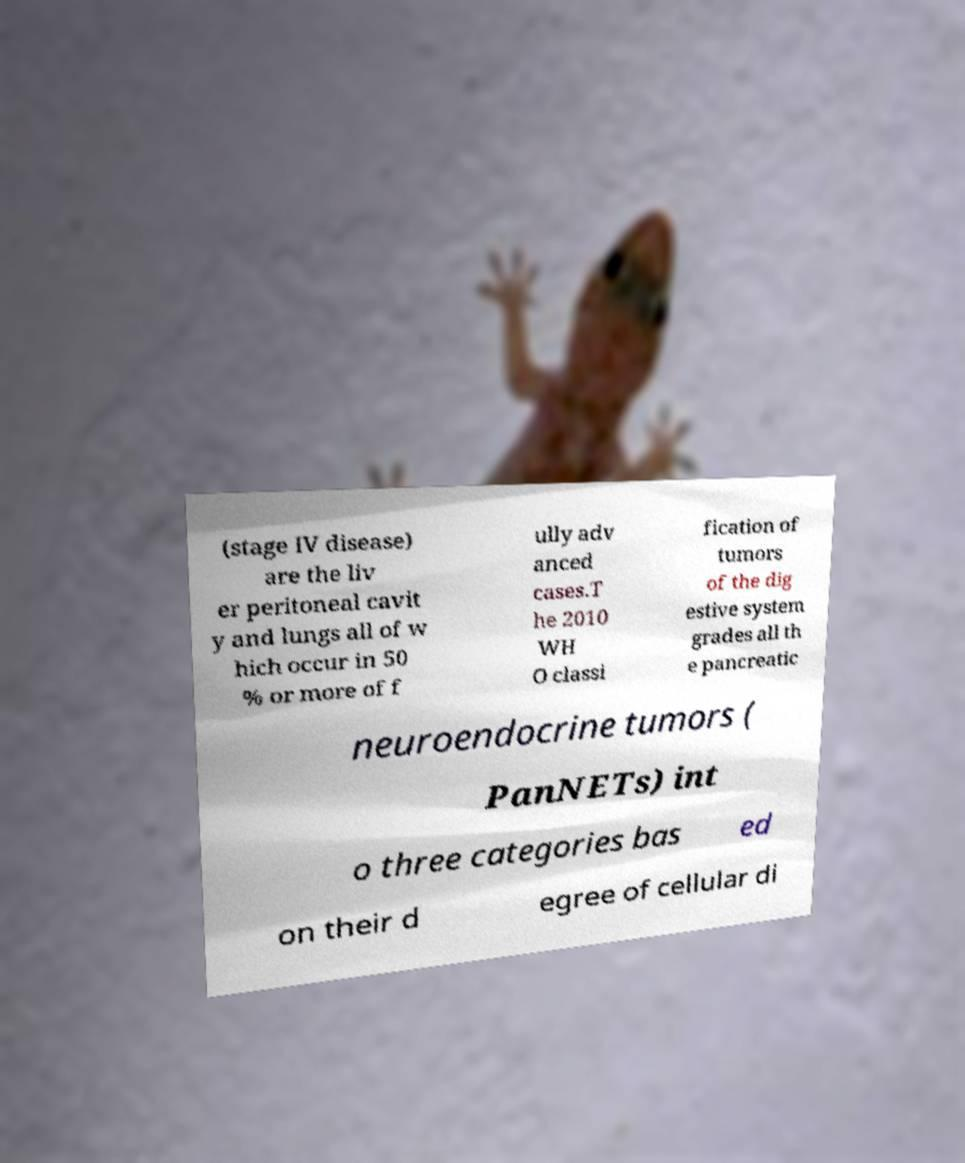Could you assist in decoding the text presented in this image and type it out clearly? (stage IV disease) are the liv er peritoneal cavit y and lungs all of w hich occur in 50 % or more of f ully adv anced cases.T he 2010 WH O classi fication of tumors of the dig estive system grades all th e pancreatic neuroendocrine tumors ( PanNETs) int o three categories bas ed on their d egree of cellular di 